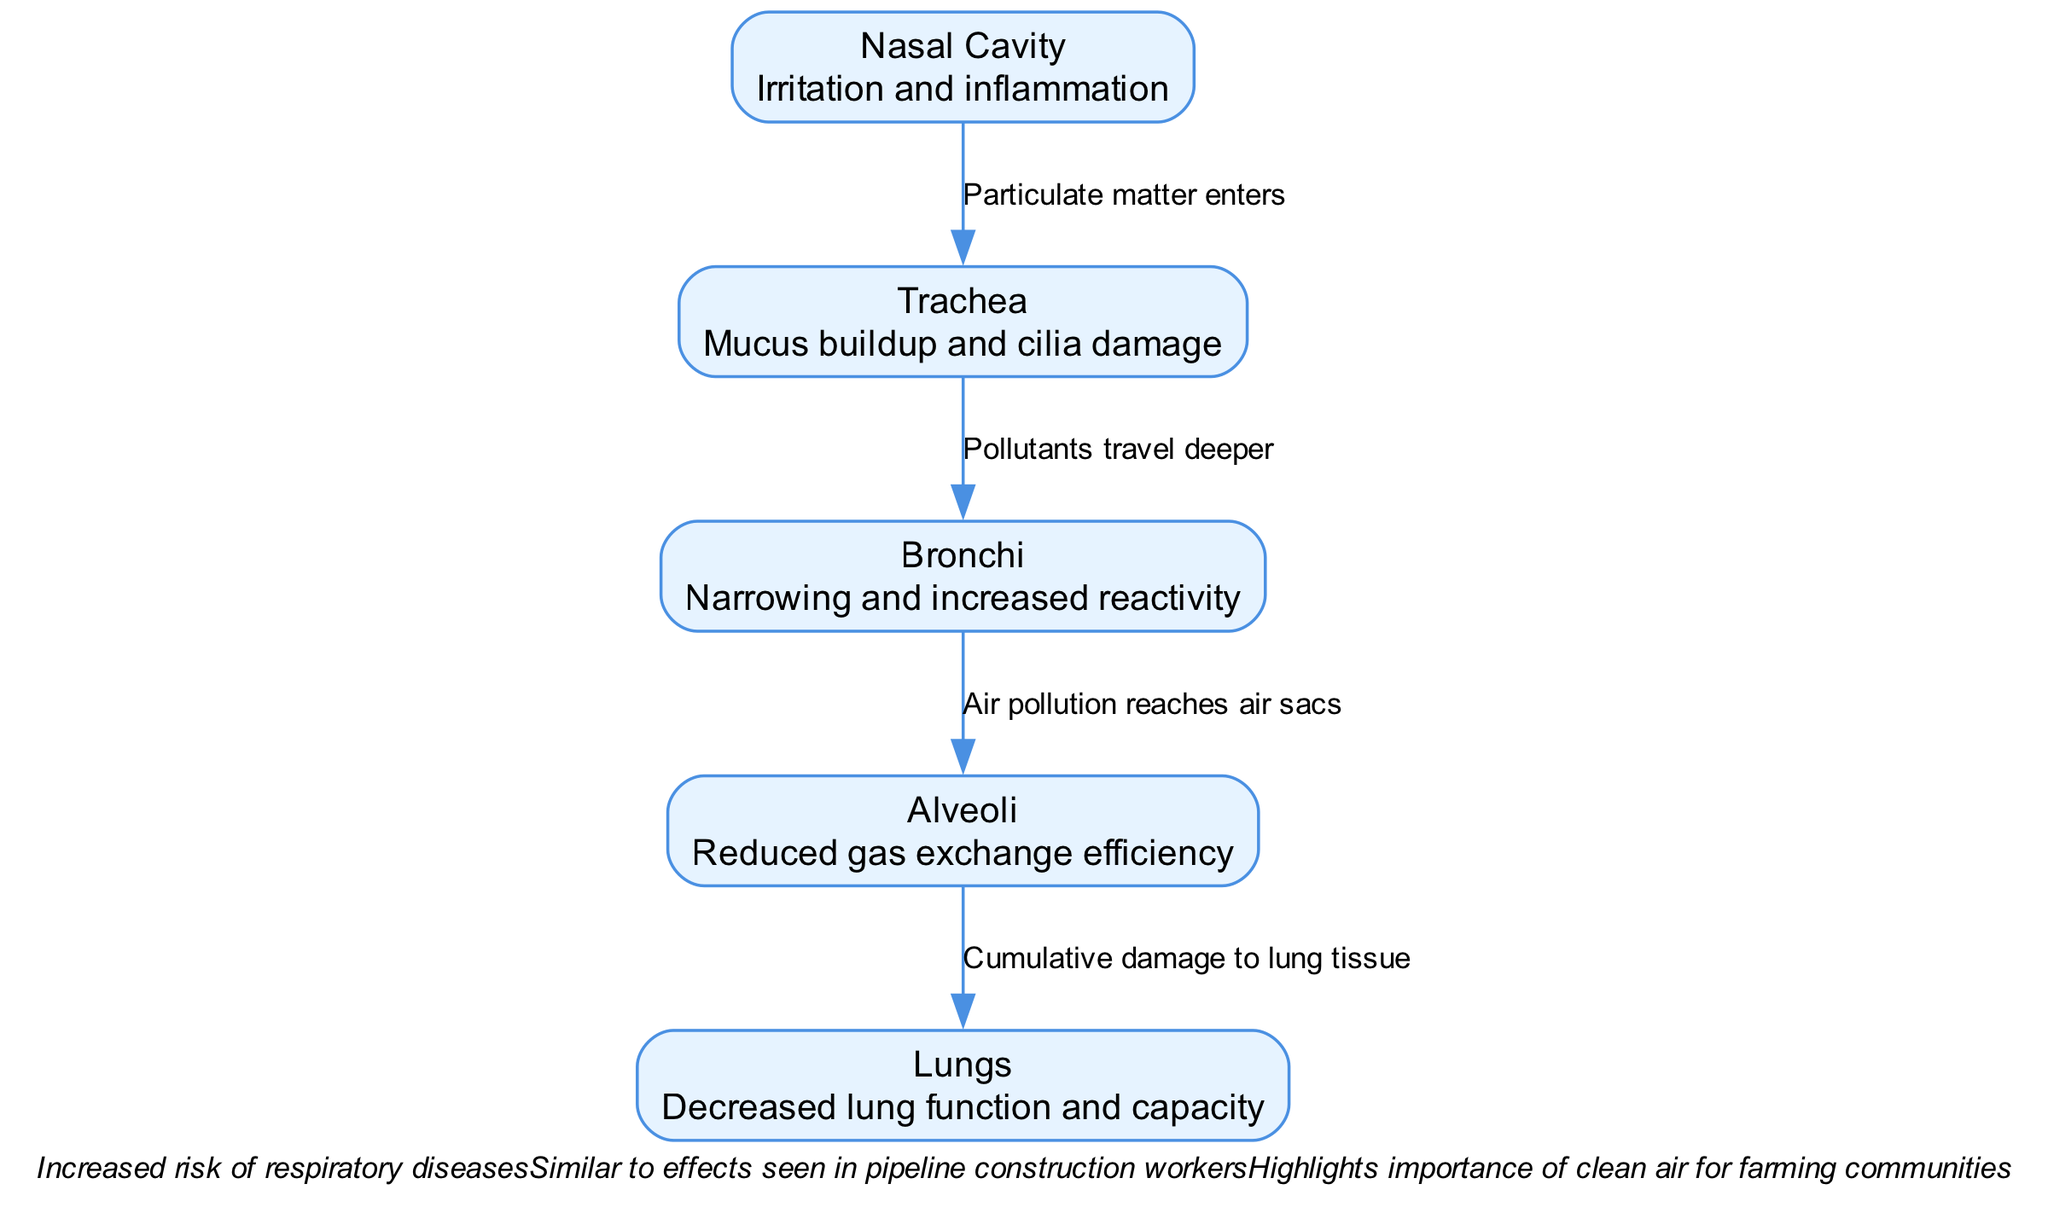What is the first node in the diagram? The first node is the "Nasal Cavity". This can be determined by looking for the node that is located at the top of the diagram and is connected to the initial edge.
Answer: Nasal Cavity What impact does air pollution have on the trachea? The description given for the trachea indicates "Mucus buildup and cilia damage". This is directly present in the diagram and can be read under the trachea node.
Answer: Mucus buildup and cilia damage How many nodes are represented in the diagram? There are five nodes illustrated in the diagram. This is counted by observing the distinct items listed within the nodes section.
Answer: 5 What is the label on the edge between the bronchi and alveoli? The edge between the bronchi and alveoli is labeled "Air pollution reaches air sacs". This label can be found on the connecting line between these two nodes.
Answer: Air pollution reaches air sacs What is the cumulative impact on the lungs due to air pollution? According to the description provided for the lungs, the impact is described as "Decreased lung function and capacity". This information is clear in the lungs node.
Answer: Decreased lung function and capacity What is the relationship between the nasal cavity and the trachea? The relationship is described with the edge label "Particulate matter enters". This implies a direct interaction where pollutants from the nasal cavity are transferred to the trachea.
Answer: Particulate matter enters What does the note mention about respiratory diseases? The note states, "Increased risk of respiratory diseases". This indicates a consequence of the interactions outlined in the diagram, summarizing the overall concern presented.
Answer: Increased risk of respiratory diseases What type of damage is noted in the alveoli? The alveoli are described as having "Reduced gas exchange efficiency". This indicates the specific effect pollution has on the air sacs in the lungs.
Answer: Reduced gas exchange efficiency What is a similar effect noted in the diagram regarding workers? The note mentions "Similar to effects seen in pipeline construction workers". This highlights a specific comparison relating to environmental and occupational health issues.
Answer: Similar to effects seen in pipeline construction workers 